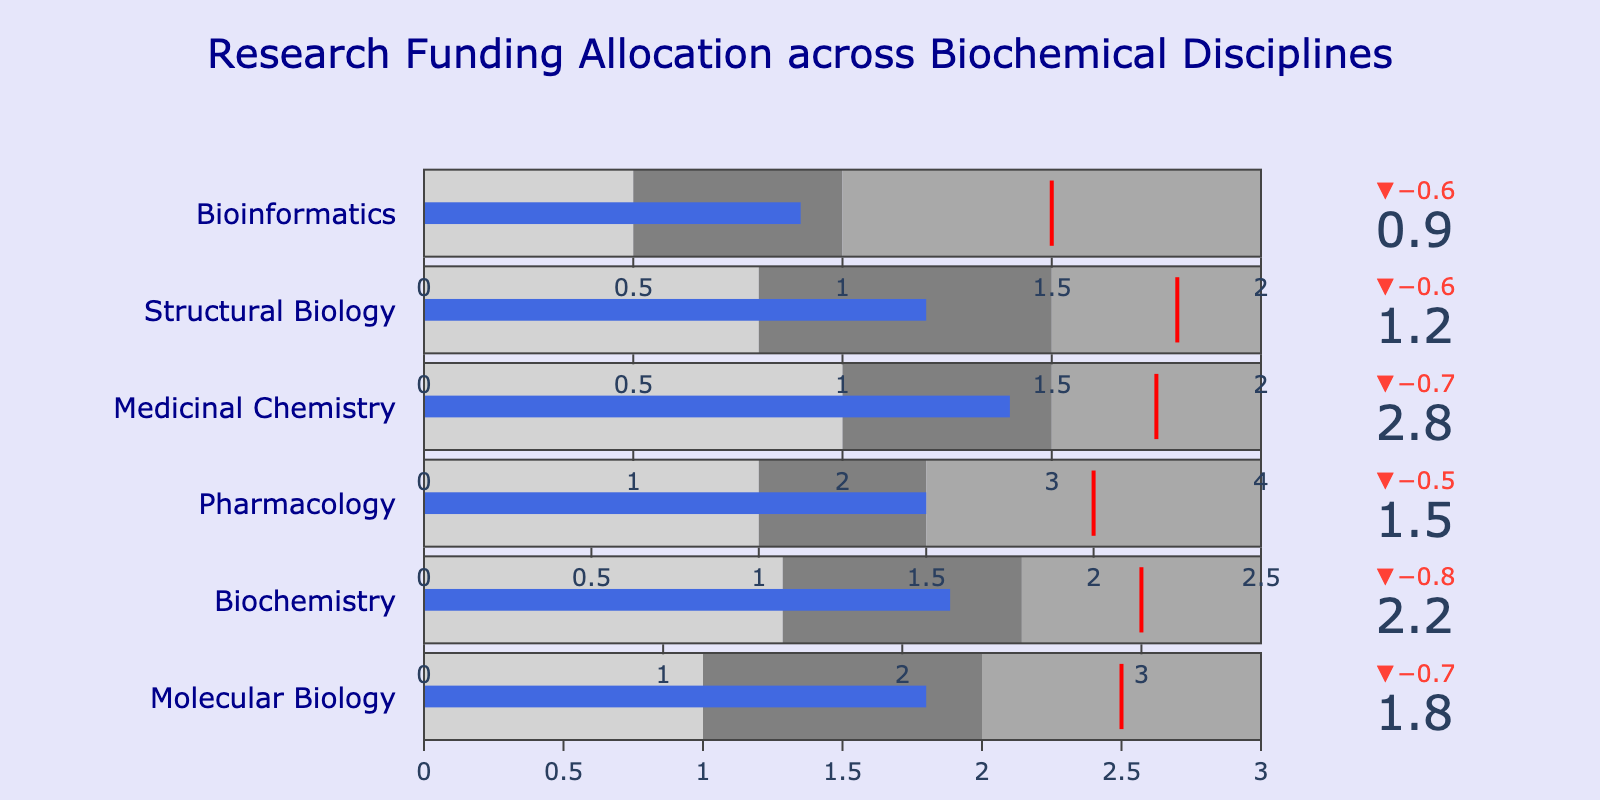What is the title of the figure? The title of the figure is usually displayed at the top center of the plot. It helps in understanding the overall context of the data presented.
Answer: Research Funding Allocation across Biochemical Disciplines Which discipline has the highest actual funding? The bullet chart shows a royal blue bar representing the actual funding for each category. By comparing the lengths, Medicinal Chemistry has the longest bar.
Answer: Medicinal Chemistry Which discipline's actual funding is closest to its target funding? The delta indicator at the top of each bullet bar shows how far the actual funding is from the target. The smallest delta indicates the closest match.
Answer: Pharmacology What is the total range of funding for the Bioinformatics discipline as represented by its gauge? The gauge represents three ranges with different gray shades, and these ranges add up to give the total range. For Bioinformatics, the gauge ranges are 0.5, 1, and 2.
Answer: 2 Which discipline has the greatest difference between its actual and target funding? To find the greatest difference, we look at the delta indicators. The largest delta value shows the greatest difference.
Answer: Medicinal Chemistry If the university reallocates funding to meet the target for Structural Biology, how much additional funding is needed? Subtract the actual funding from the target funding for Structural Biology: \(1.8 - 1.2 = 0.6\).
Answer: 0.6 Compare the actual funding of Molecular Biology and Biochemistry. Which one is greater and by how much? Molecular Biology and Biochemistry's actual funding are 1.8 and 2.2, respectively. Subtract the smaller value from the larger value: \(2.2 - 1.8 = 0.4\).
Answer: Biochemistry by 0.4 Is the actual funding for any discipline below the first range threshold? The first range threshold varies by discipline; we need to check each discipline's actual funding against this threshold. Only Bioinformatics (actual 0.9, first range threshold 0.5) is below the threshold.
Answer: No Which disciplines exceed their first range threshold but do not meet the second range threshold? Compare the actual funding with the ranges for each discipline and find those falling between the first and second thresholds. Molecular Biology, Biochemistry, Pharmacology, and Bioinformatics fall in this category.
Answer: Molecular Biology, Biochemistry, Pharmacology, and Bioinformatics Compare the target funding for Biochemistry and Medicinal Chemistry. By how much does Medicinal Chemistry's target exceed Biochemistry's? The target funding values are given for both: Biochemistry 3.0 and Medicinal Chemistry 3.5. Subtract to find the difference: \(3.5 - 3.0 = 0.5\).
Answer: 0.5 